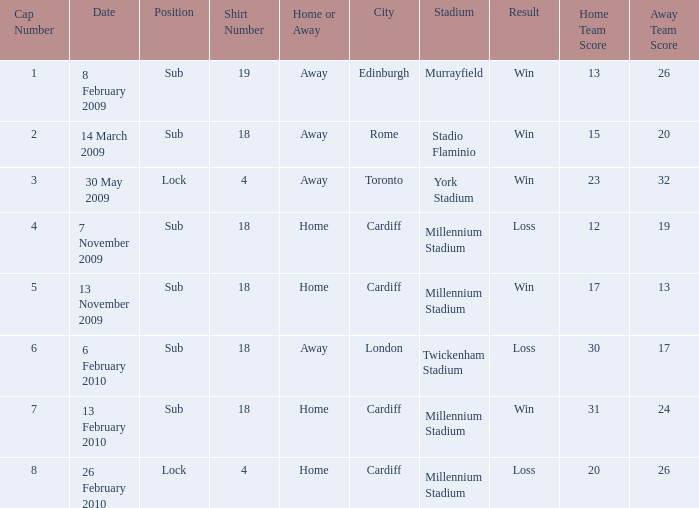Can you tell me the Home or the Away that has the Shirt Number larger than 18? Away. 